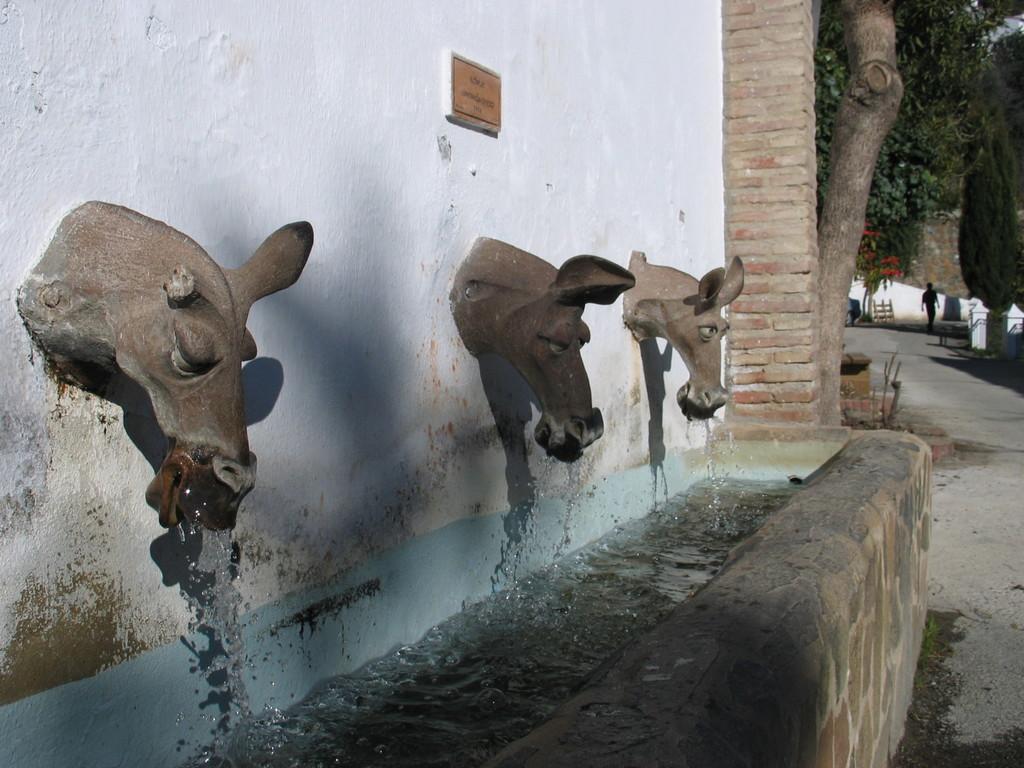Could you give a brief overview of what you see in this image? As we can see in the image there is a white color wall, statues, trees and a person walking on road. 